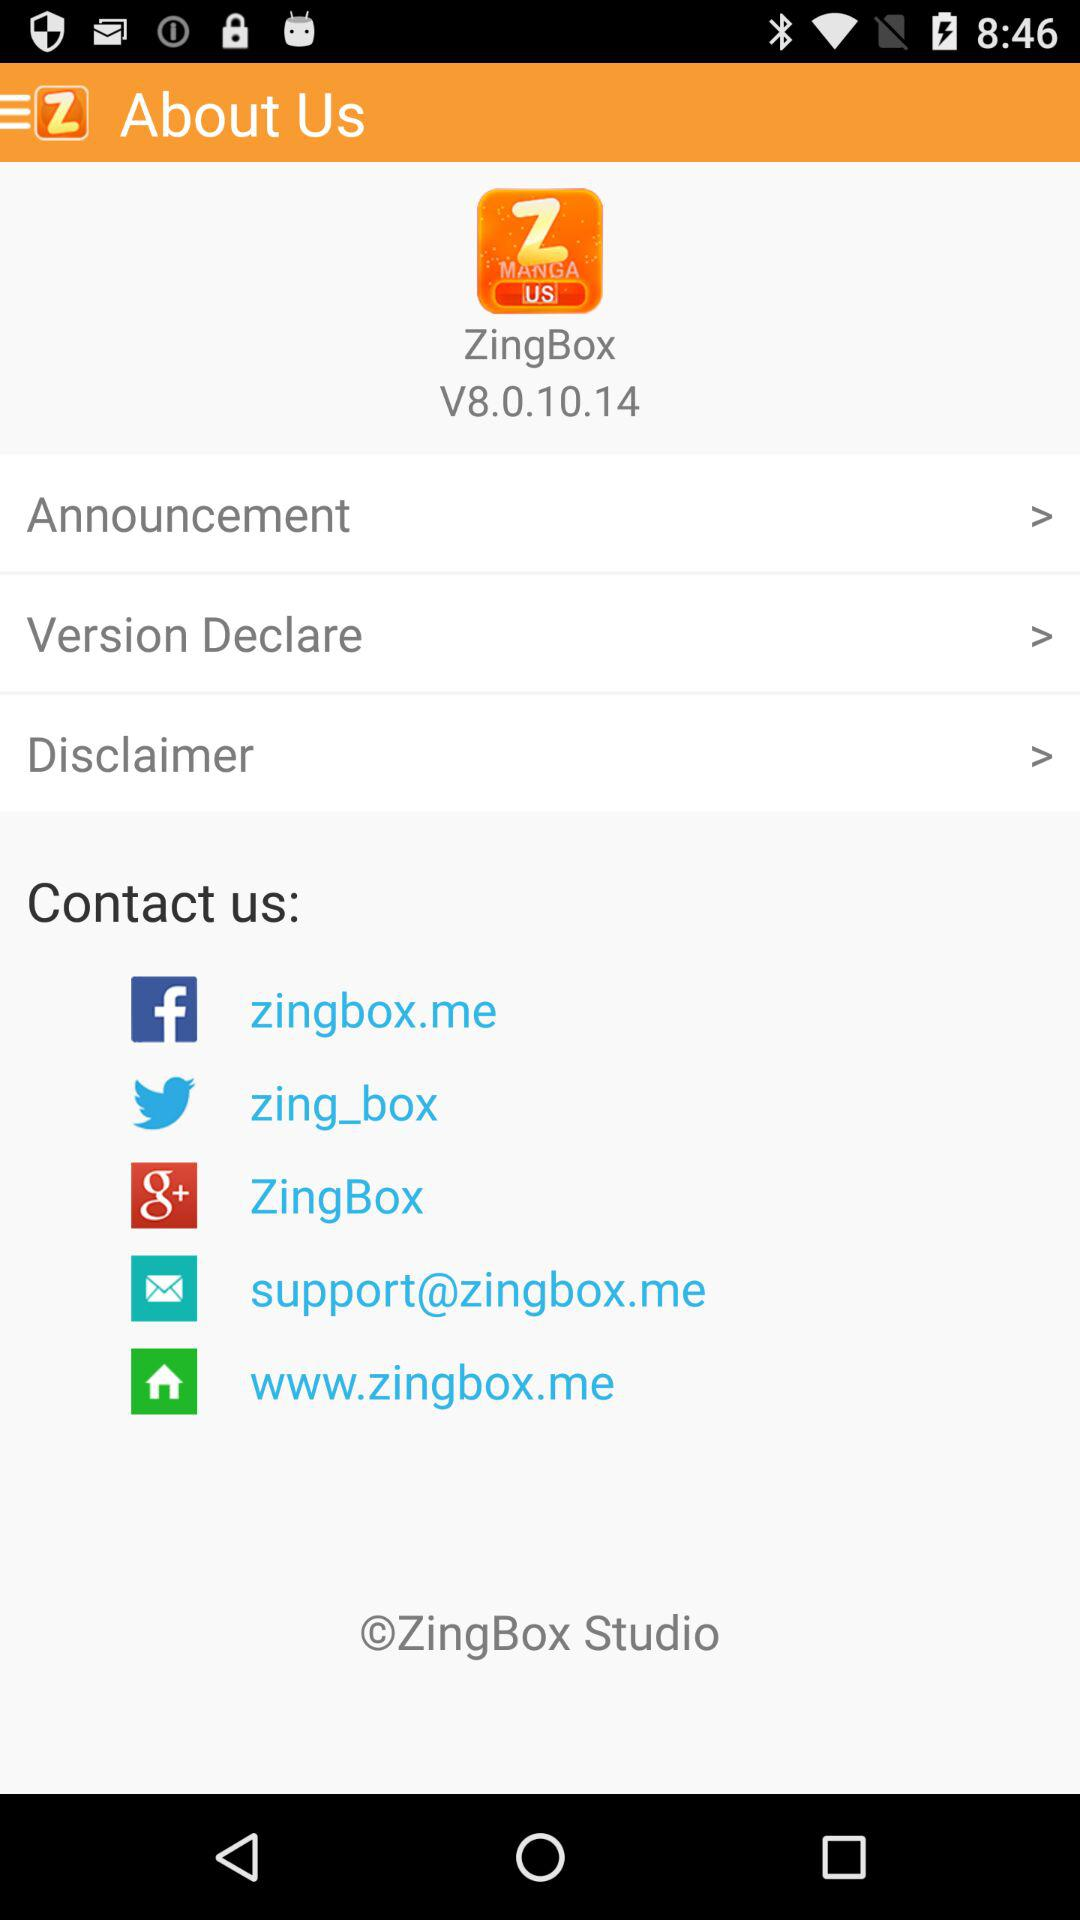What is the version? The version is 8.0.10.14. 